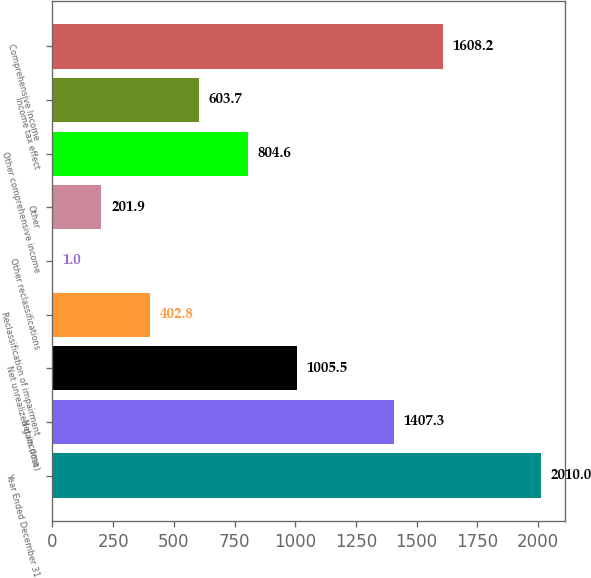Convert chart to OTSL. <chart><loc_0><loc_0><loc_500><loc_500><bar_chart><fcel>Year Ended December 31<fcel>Net income<fcel>Net unrealized gain (loss)<fcel>Reclassification of impairment<fcel>Other reclassifications<fcel>Other<fcel>Other comprehensive income<fcel>Income tax effect<fcel>Comprehensive Income<nl><fcel>2010<fcel>1407.3<fcel>1005.5<fcel>402.8<fcel>1<fcel>201.9<fcel>804.6<fcel>603.7<fcel>1608.2<nl></chart> 